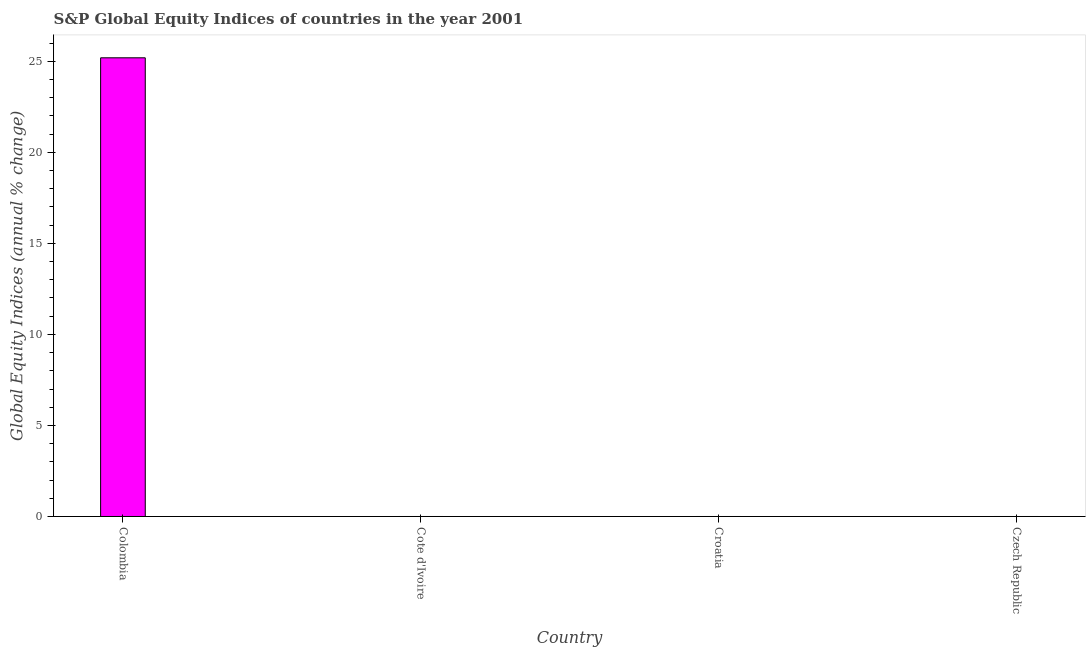Does the graph contain any zero values?
Your response must be concise. Yes. Does the graph contain grids?
Ensure brevity in your answer.  No. What is the title of the graph?
Offer a very short reply. S&P Global Equity Indices of countries in the year 2001. What is the label or title of the X-axis?
Give a very brief answer. Country. What is the label or title of the Y-axis?
Your answer should be very brief. Global Equity Indices (annual % change). What is the s&p global equity indices in Cote d'Ivoire?
Offer a terse response. 0. Across all countries, what is the maximum s&p global equity indices?
Keep it short and to the point. 25.19. In which country was the s&p global equity indices maximum?
Offer a terse response. Colombia. What is the sum of the s&p global equity indices?
Offer a terse response. 25.19. What is the average s&p global equity indices per country?
Offer a very short reply. 6.3. What is the median s&p global equity indices?
Offer a terse response. 0. What is the difference between the highest and the lowest s&p global equity indices?
Provide a succinct answer. 25.19. How many bars are there?
Your answer should be compact. 1. How many countries are there in the graph?
Give a very brief answer. 4. What is the difference between two consecutive major ticks on the Y-axis?
Offer a terse response. 5. What is the Global Equity Indices (annual % change) in Colombia?
Your answer should be very brief. 25.19. 